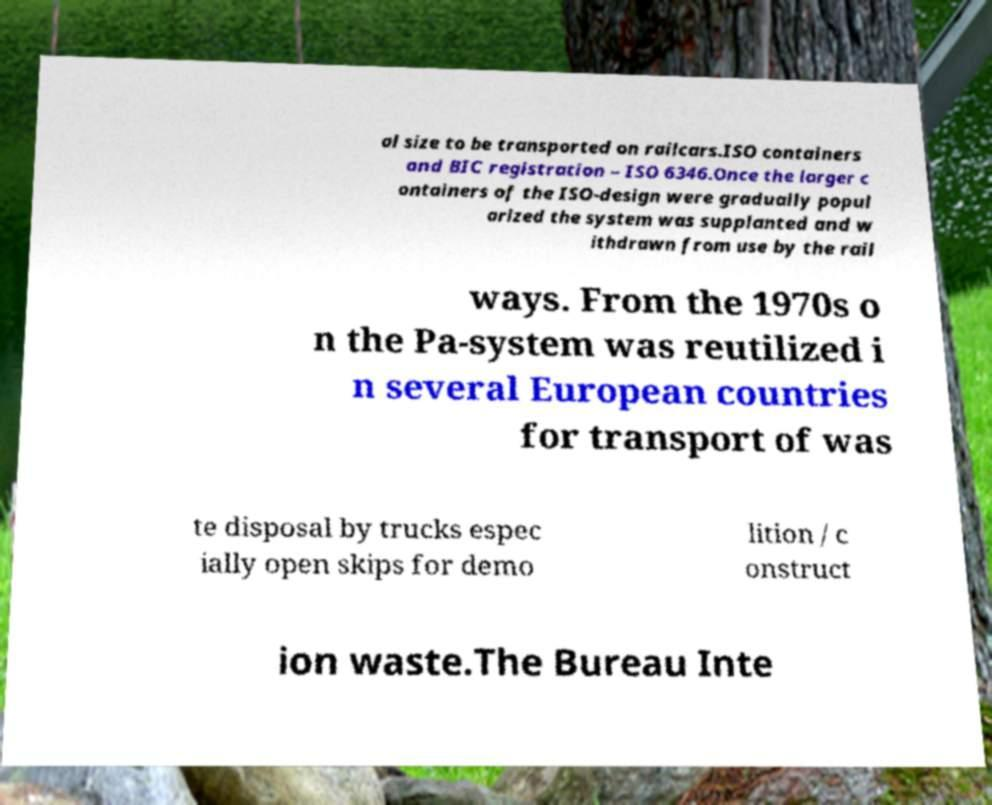I need the written content from this picture converted into text. Can you do that? al size to be transported on railcars.ISO containers and BIC registration – ISO 6346.Once the larger c ontainers of the ISO-design were gradually popul arized the system was supplanted and w ithdrawn from use by the rail ways. From the 1970s o n the Pa-system was reutilized i n several European countries for transport of was te disposal by trucks espec ially open skips for demo lition / c onstruct ion waste.The Bureau Inte 